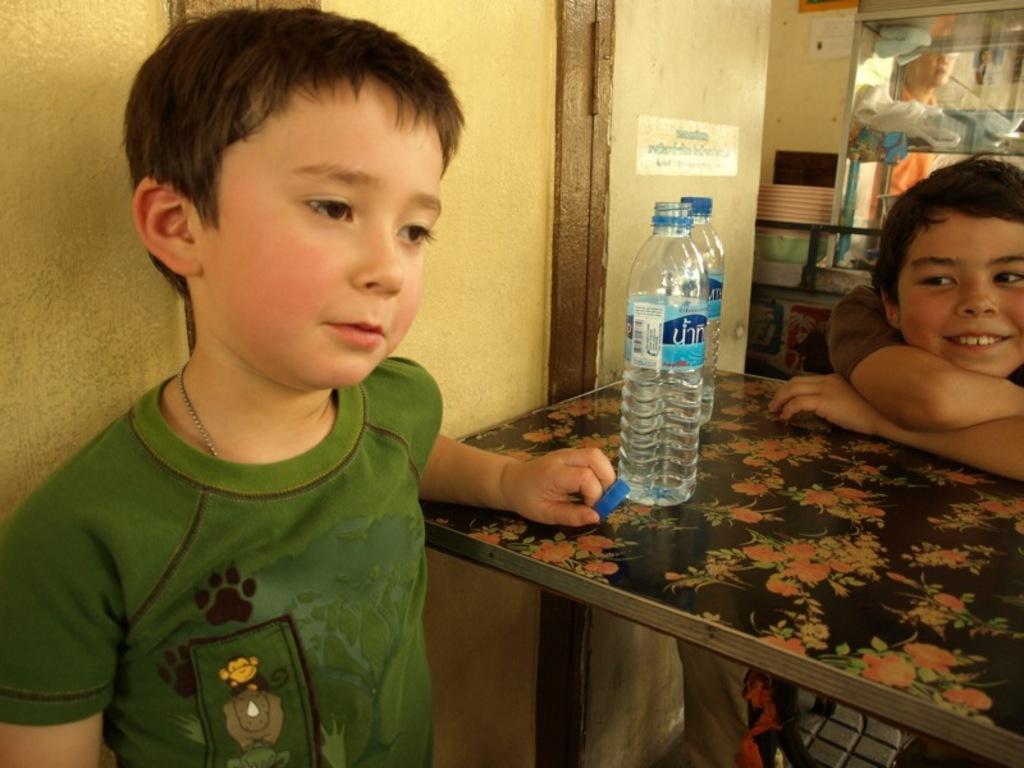Describe this image in one or two sentences. There are 2 boys to the either side of the table. There are 2 water bottles on the table. Behind them we can see a wall and a person. 